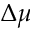Convert formula to latex. <formula><loc_0><loc_0><loc_500><loc_500>\Delta \mu</formula> 